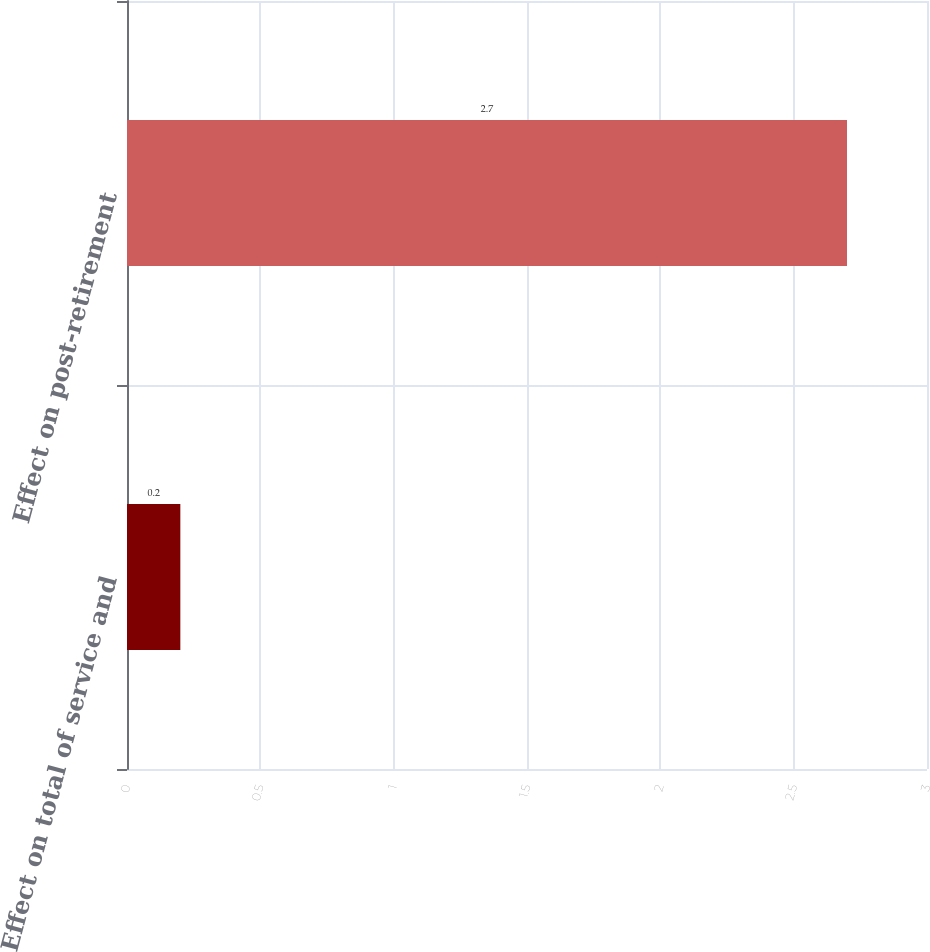Convert chart to OTSL. <chart><loc_0><loc_0><loc_500><loc_500><bar_chart><fcel>Effect on total of service and<fcel>Effect on post-retirement<nl><fcel>0.2<fcel>2.7<nl></chart> 